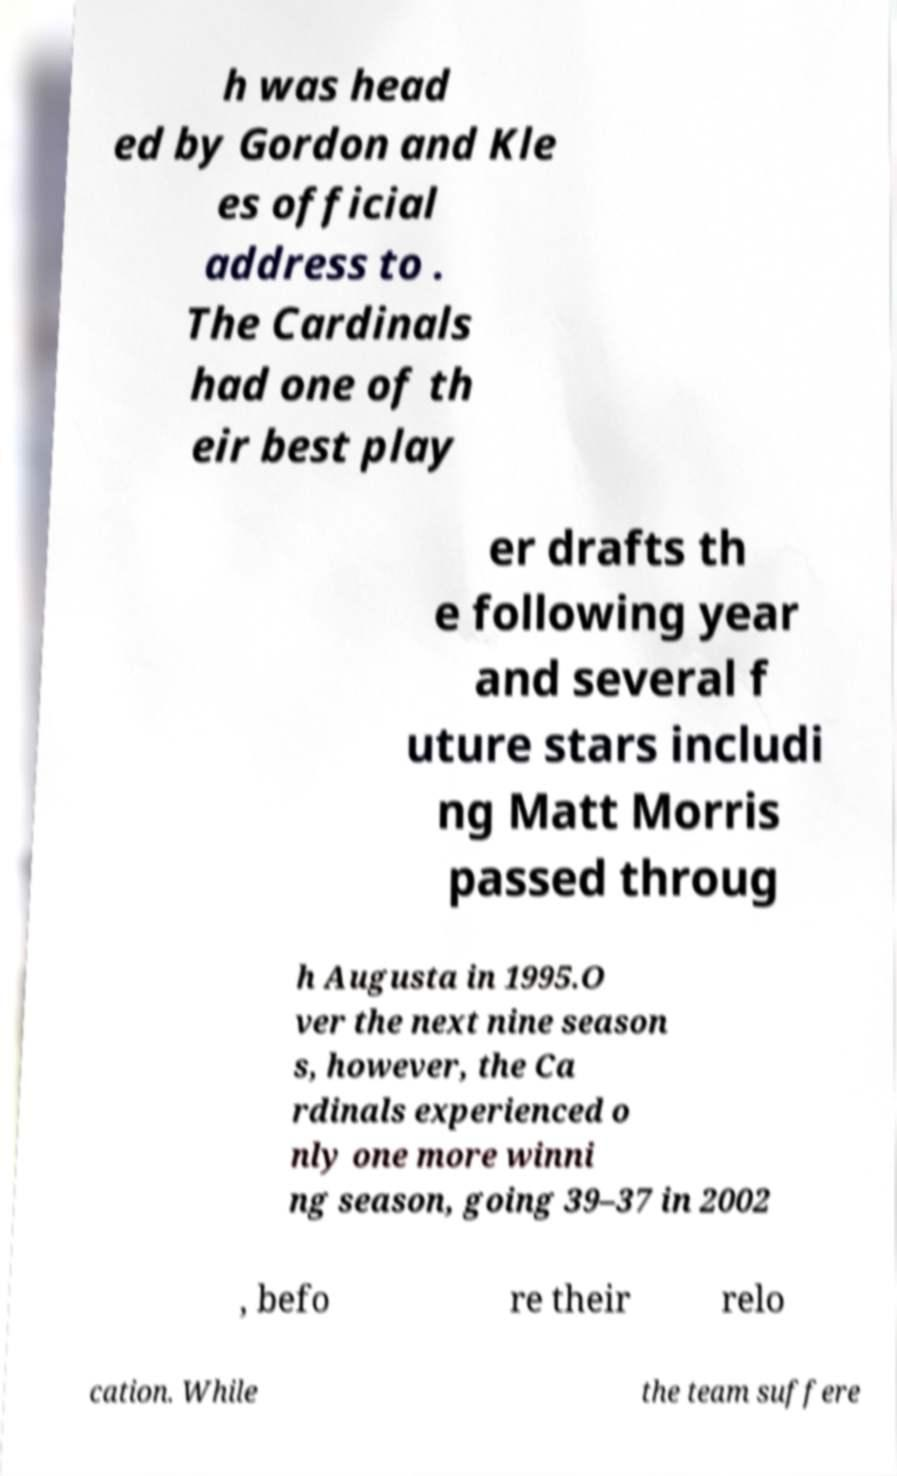Please read and relay the text visible in this image. What does it say? h was head ed by Gordon and Kle es official address to . The Cardinals had one of th eir best play er drafts th e following year and several f uture stars includi ng Matt Morris passed throug h Augusta in 1995.O ver the next nine season s, however, the Ca rdinals experienced o nly one more winni ng season, going 39–37 in 2002 , befo re their relo cation. While the team suffere 